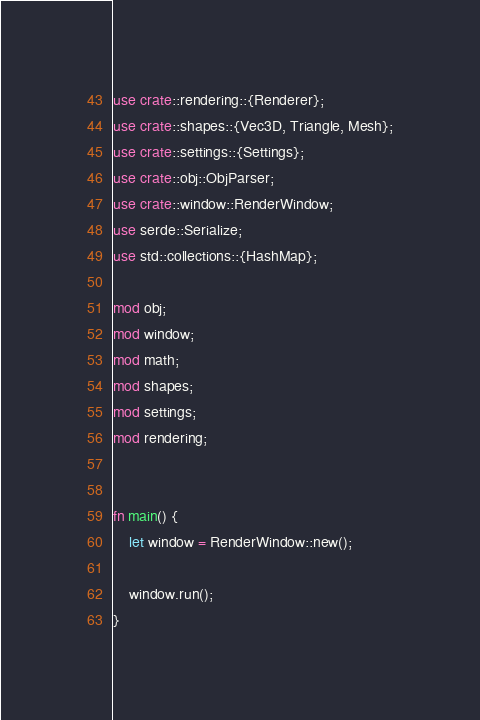Convert code to text. <code><loc_0><loc_0><loc_500><loc_500><_Rust_>use crate::rendering::{Renderer};
use crate::shapes::{Vec3D, Triangle, Mesh};
use crate::settings::{Settings};
use crate::obj::ObjParser;
use crate::window::RenderWindow;
use serde::Serialize;
use std::collections::{HashMap};

mod obj;
mod window;
mod math;
mod shapes;
mod settings;
mod rendering;


fn main() {
    let window = RenderWindow::new();

    window.run();
}</code> 